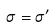<formula> <loc_0><loc_0><loc_500><loc_500>\sigma = \sigma ^ { \prime }</formula> 